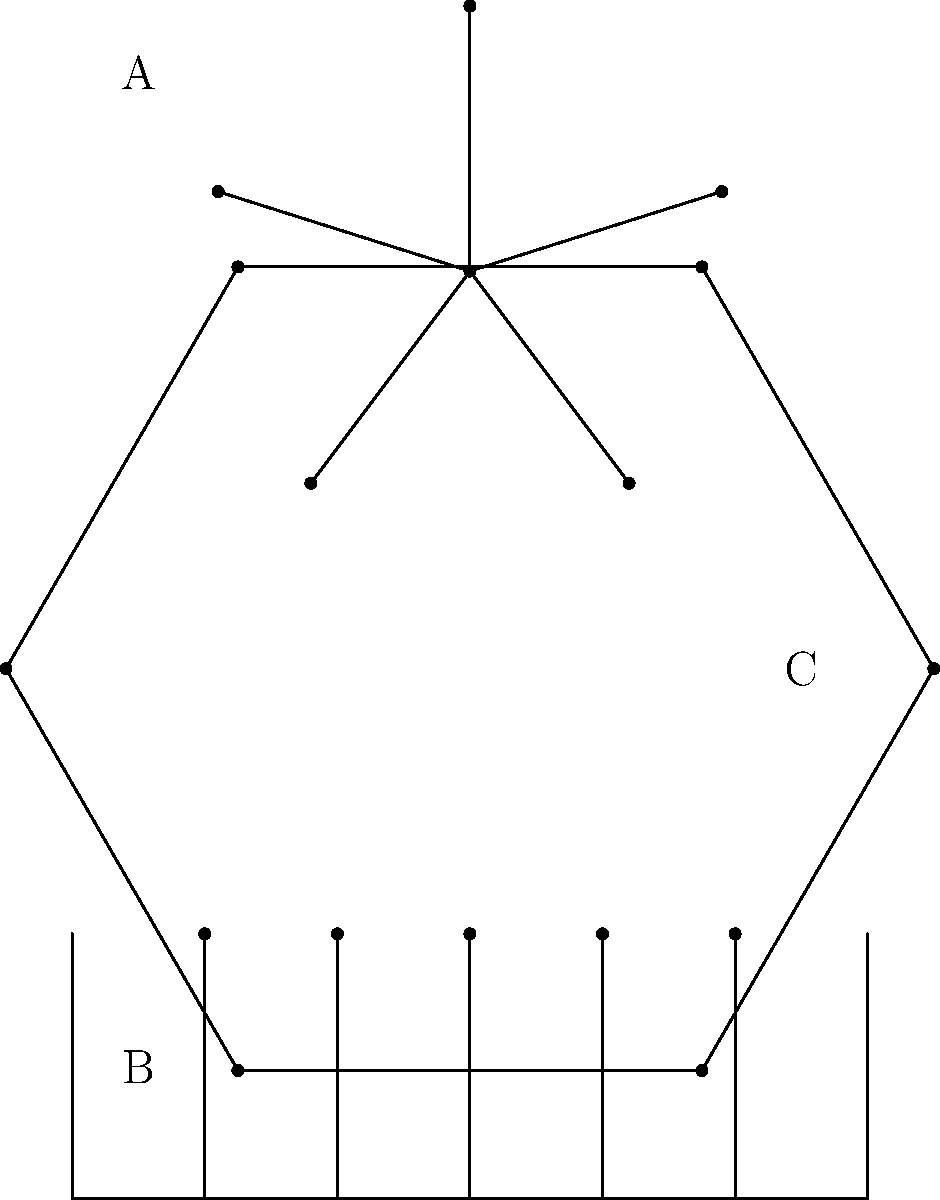Identify the network topology labeled 'C' in the diagram. To identify the correct network topology, let's analyze each of the three topologies shown in the diagram:

1. Topology A (top):
   - Central node connected to multiple peripheral nodes
   - This is a star topology

2. Topology B (middle):
   - Single linear connection with multiple nodes attached
   - This is a bus topology

3. Topology C (bottom-right):
   - Nodes connected in a circular arrangement
   - Each node is connected to exactly two other nodes
   - Forms a closed loop

The characteristics of Topology C match those of a ring topology. In a ring topology:
   - Data travels in a circular path
   - Each device has exactly two neighbors for communication purposes
   - All nodes are connected in a closed loop

Therefore, the network topology labeled 'C' in the diagram is a ring topology.
Answer: Ring topology 